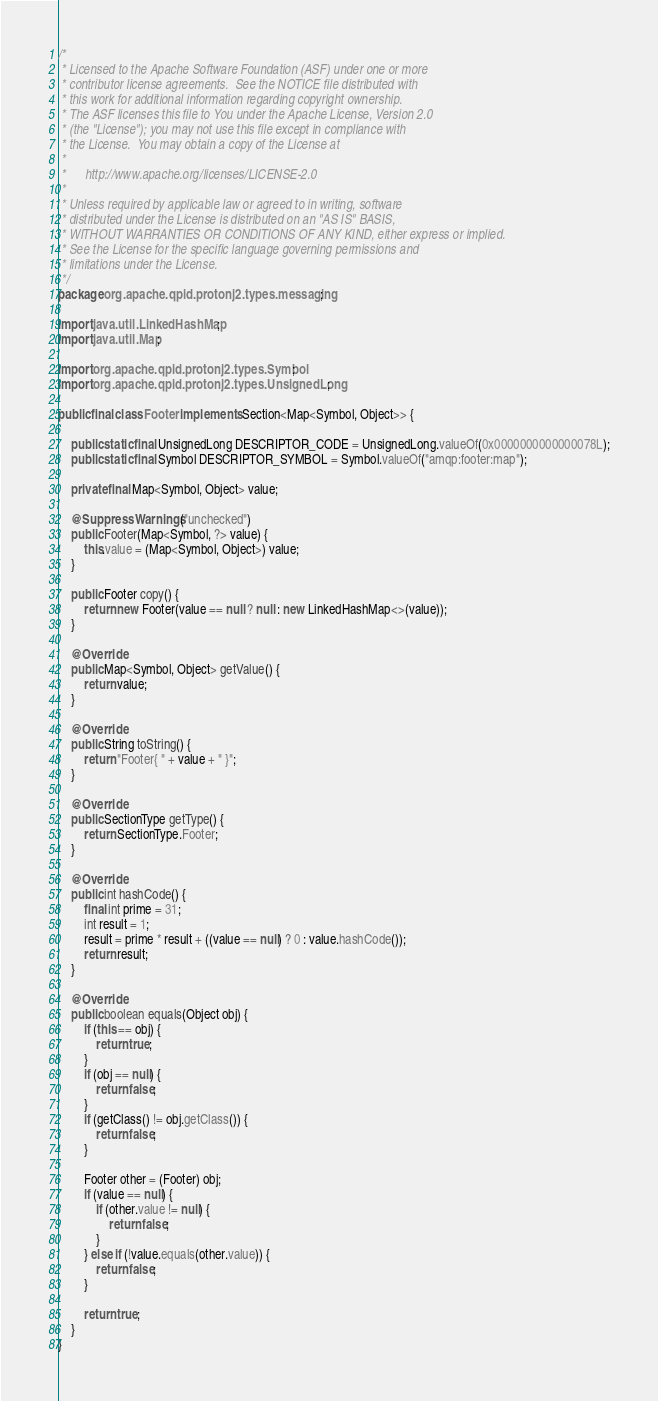<code> <loc_0><loc_0><loc_500><loc_500><_Java_>/*
 * Licensed to the Apache Software Foundation (ASF) under one or more
 * contributor license agreements.  See the NOTICE file distributed with
 * this work for additional information regarding copyright ownership.
 * The ASF licenses this file to You under the Apache License, Version 2.0
 * (the "License"); you may not use this file except in compliance with
 * the License.  You may obtain a copy of the License at
 *
 *      http://www.apache.org/licenses/LICENSE-2.0
 *
 * Unless required by applicable law or agreed to in writing, software
 * distributed under the License is distributed on an "AS IS" BASIS,
 * WITHOUT WARRANTIES OR CONDITIONS OF ANY KIND, either express or implied.
 * See the License for the specific language governing permissions and
 * limitations under the License.
 */
package org.apache.qpid.protonj2.types.messaging;

import java.util.LinkedHashMap;
import java.util.Map;

import org.apache.qpid.protonj2.types.Symbol;
import org.apache.qpid.protonj2.types.UnsignedLong;

public final class Footer implements Section<Map<Symbol, Object>> {

    public static final UnsignedLong DESCRIPTOR_CODE = UnsignedLong.valueOf(0x0000000000000078L);
    public static final Symbol DESCRIPTOR_SYMBOL = Symbol.valueOf("amqp:footer:map");

    private final Map<Symbol, Object> value;

    @SuppressWarnings("unchecked")
    public Footer(Map<Symbol, ?> value) {
        this.value = (Map<Symbol, Object>) value;
    }

    public Footer copy() {
        return new Footer(value == null ? null : new LinkedHashMap<>(value));
    }

    @Override
    public Map<Symbol, Object> getValue() {
        return value;
    }

    @Override
    public String toString() {
        return "Footer{ " + value + " }";
    }

    @Override
    public SectionType getType() {
        return SectionType.Footer;
    }

    @Override
    public int hashCode() {
        final int prime = 31;
        int result = 1;
        result = prime * result + ((value == null) ? 0 : value.hashCode());
        return result;
    }

    @Override
    public boolean equals(Object obj) {
        if (this == obj) {
            return true;
        }
        if (obj == null) {
            return false;
        }
        if (getClass() != obj.getClass()) {
            return false;
        }

        Footer other = (Footer) obj;
        if (value == null) {
            if (other.value != null) {
                return false;
            }
        } else if (!value.equals(other.value)) {
            return false;
        }

        return true;
    }
}
</code> 